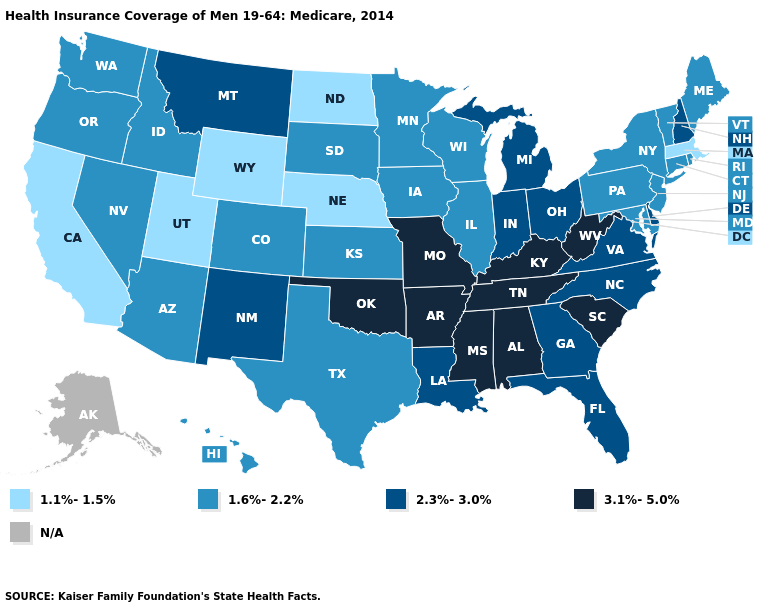Does Iowa have the highest value in the MidWest?
Concise answer only. No. What is the lowest value in the USA?
Be succinct. 1.1%-1.5%. Name the states that have a value in the range 1.1%-1.5%?
Answer briefly. California, Massachusetts, Nebraska, North Dakota, Utah, Wyoming. What is the highest value in the USA?
Short answer required. 3.1%-5.0%. What is the lowest value in the USA?
Keep it brief. 1.1%-1.5%. What is the value of Alaska?
Answer briefly. N/A. Does New Jersey have the highest value in the Northeast?
Concise answer only. No. What is the highest value in the South ?
Answer briefly. 3.1%-5.0%. What is the value of Maine?
Keep it brief. 1.6%-2.2%. Name the states that have a value in the range 1.6%-2.2%?
Keep it brief. Arizona, Colorado, Connecticut, Hawaii, Idaho, Illinois, Iowa, Kansas, Maine, Maryland, Minnesota, Nevada, New Jersey, New York, Oregon, Pennsylvania, Rhode Island, South Dakota, Texas, Vermont, Washington, Wisconsin. Name the states that have a value in the range 3.1%-5.0%?
Short answer required. Alabama, Arkansas, Kentucky, Mississippi, Missouri, Oklahoma, South Carolina, Tennessee, West Virginia. Does New Hampshire have the highest value in the USA?
Concise answer only. No. How many symbols are there in the legend?
Concise answer only. 5. What is the lowest value in the MidWest?
Concise answer only. 1.1%-1.5%. 